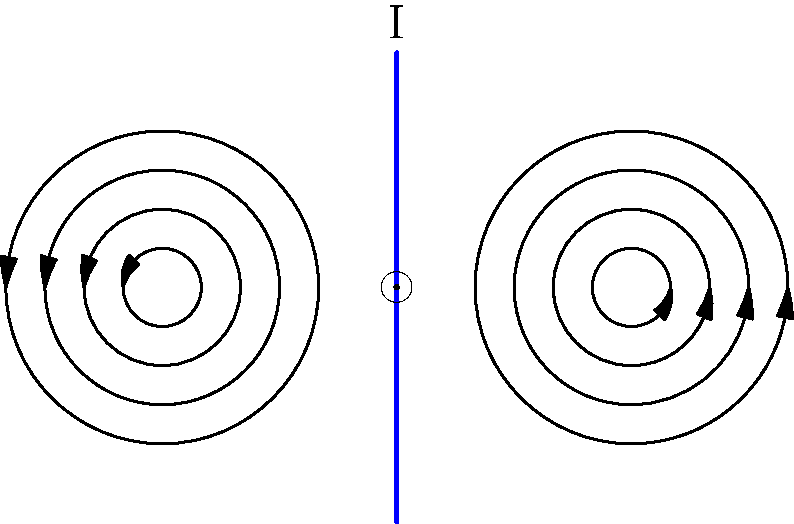In the context of discourse analysis, how might the visual representation of magnetic field lines around a current-carrying wire contribute to understanding the structure of scientific arguments about electromagnetic phenomena? To answer this question, we need to consider several aspects of discourse analysis and how they relate to the visual representation of magnetic field lines:

1. Visual rhetoric: The circular pattern of the magnetic field lines provides a clear, concise representation of a complex physical phenomenon. This visual element can serve as a powerful rhetorical device in scientific discourse.

2. Conceptual metaphors: The circular field lines can be seen as a metaphor for the interconnectedness of magnetic and electric phenomena, potentially influencing how scientists conceptualize and discuss electromagnetic interactions.

3. Argumentation structure: The diagram supports the right-hand rule for determining the direction of magnetic fields, which can be used as a premise in arguments about electromagnetic interactions.

4. Multimodal discourse: The combination of the visual representation with mathematical and verbal descriptions creates a multimodal discourse that can enhance understanding and persuasion in scientific arguments.

5. Cognitive accessibility: The visual representation makes abstract concepts more cognitively accessible, potentially facilitating more effective communication and argumentation among scientists and non-experts alike.

6. Intertextuality: This standardized representation allows for easier reference and comparison across different scientific texts and arguments, enhancing the coherence of the broader scientific discourse on electromagnetism.

7. Discourse markers: The arrows on the field lines serve as visual discourse markers, guiding the reader's interpretation and supporting claims about the field's direction and behavior.

8. Argumentative scaffolding: The visual representation can act as a scaffold for building more complex arguments about electromagnetic phenomena, providing a shared reference point for discussants.
Answer: The visual representation enhances scientific argumentation by providing a rhetorical device, conceptual metaphor, multimodal discourse element, and cognitive scaffold for discussing electromagnetic phenomena. 